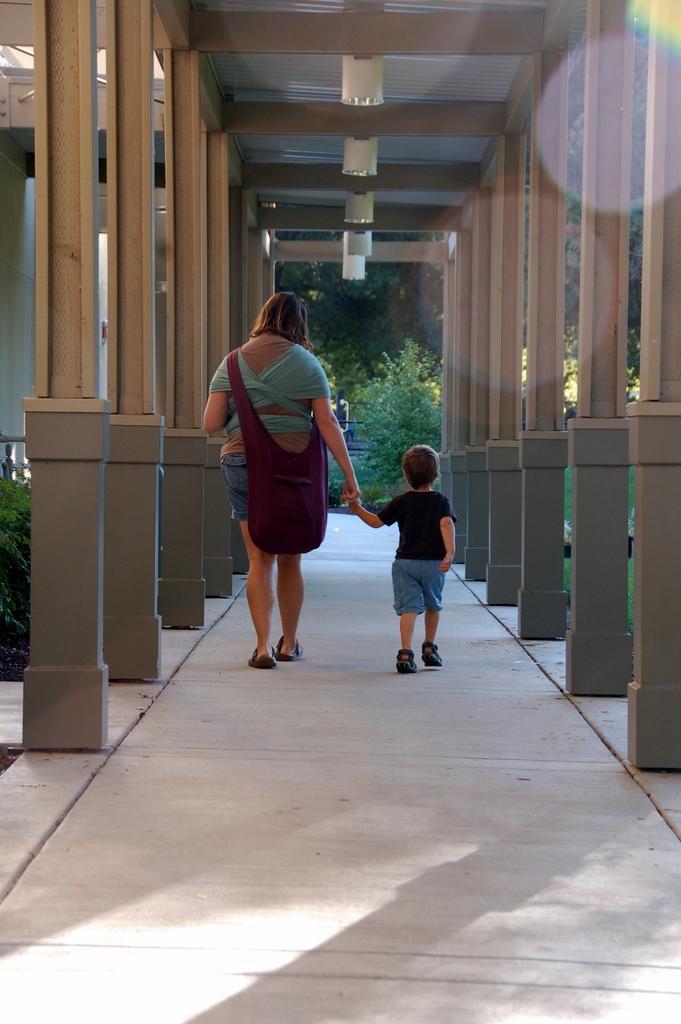Could you give a brief overview of what you see in this image? In this picture we can see a woman and boy walking on a path, she is carrying a bag, side we can see some pillories and some plants. 